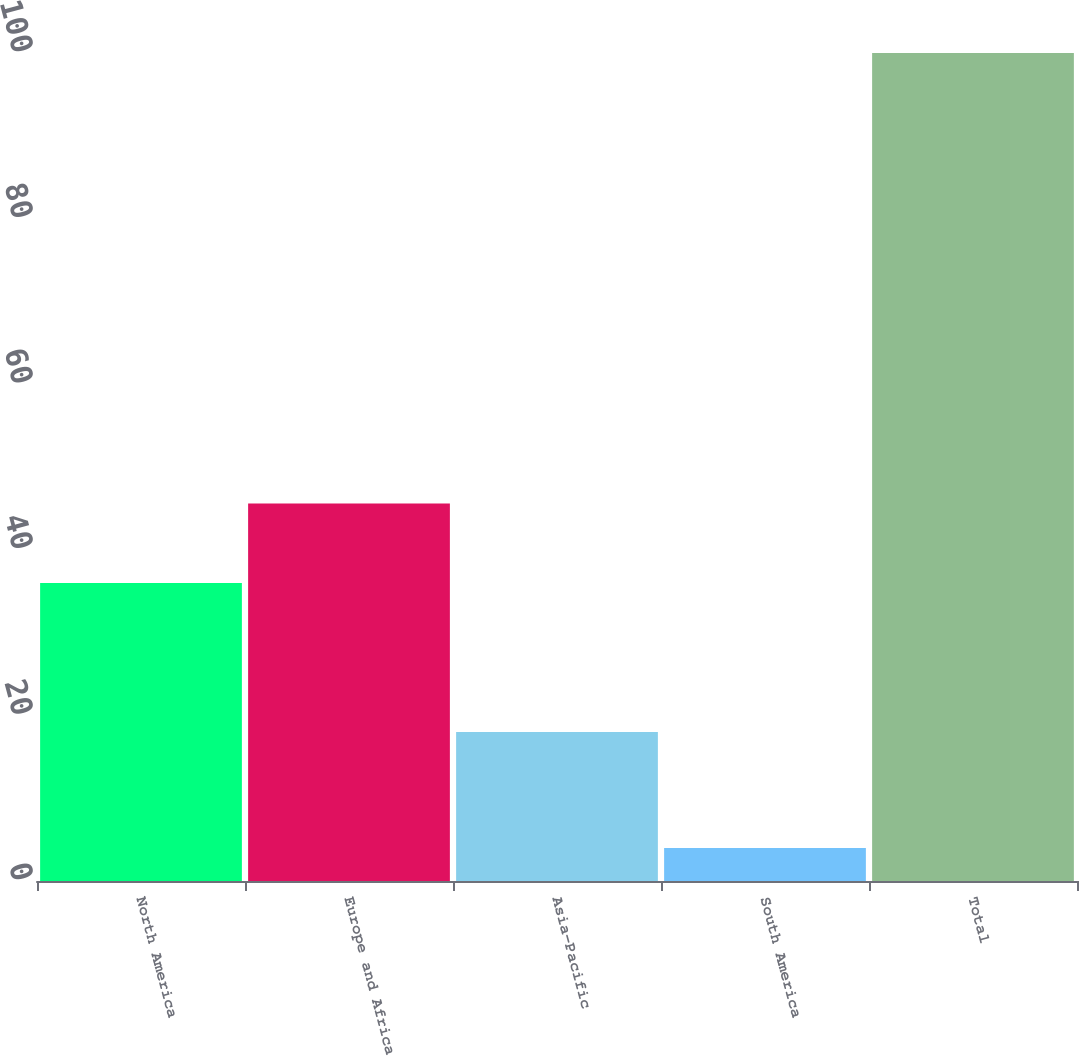Convert chart to OTSL. <chart><loc_0><loc_0><loc_500><loc_500><bar_chart><fcel>North America<fcel>Europe and Africa<fcel>Asia-Pacific<fcel>South America<fcel>Total<nl><fcel>36<fcel>45.6<fcel>18<fcel>4<fcel>100<nl></chart> 